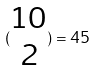Convert formula to latex. <formula><loc_0><loc_0><loc_500><loc_500>( \begin{matrix} 1 0 \\ 2 \end{matrix} ) = 4 5</formula> 